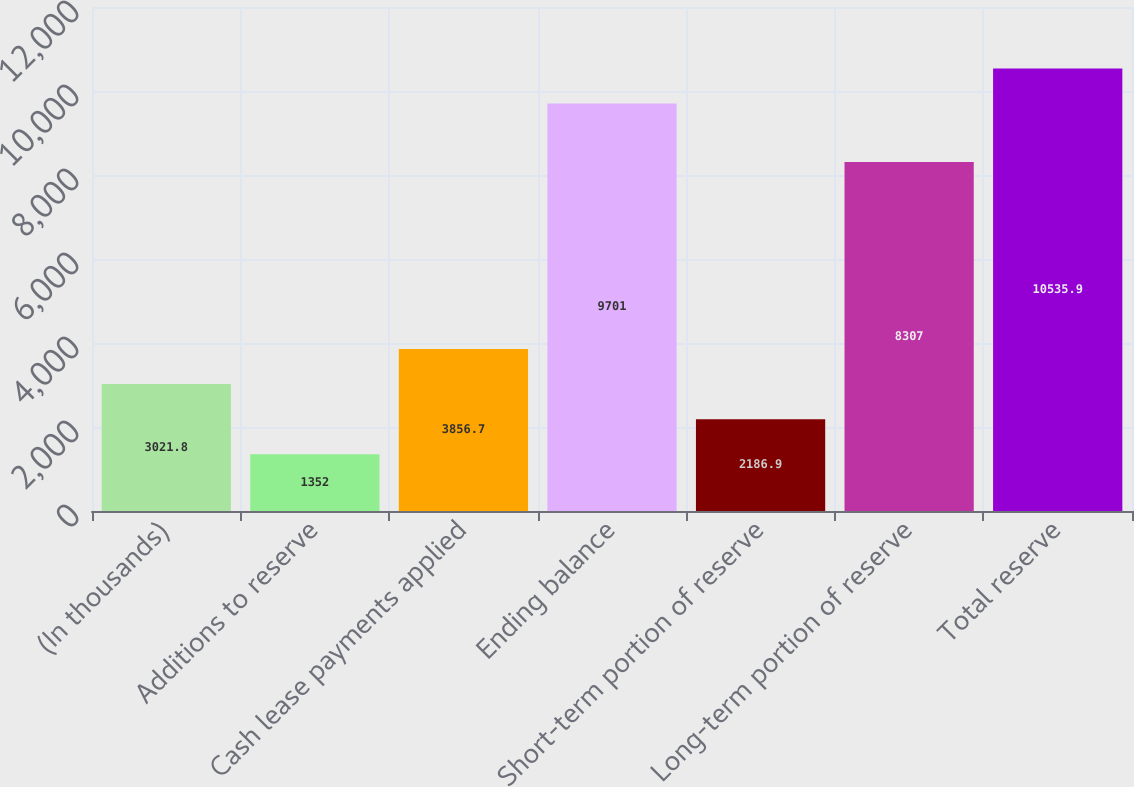<chart> <loc_0><loc_0><loc_500><loc_500><bar_chart><fcel>(In thousands)<fcel>Additions to reserve<fcel>Cash lease payments applied<fcel>Ending balance<fcel>Short-term portion of reserve<fcel>Long-term portion of reserve<fcel>Total reserve<nl><fcel>3021.8<fcel>1352<fcel>3856.7<fcel>9701<fcel>2186.9<fcel>8307<fcel>10535.9<nl></chart> 